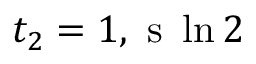<formula> <loc_0><loc_0><loc_500><loc_500>t _ { 2 } = 1 , s \ln { 2 }</formula> 